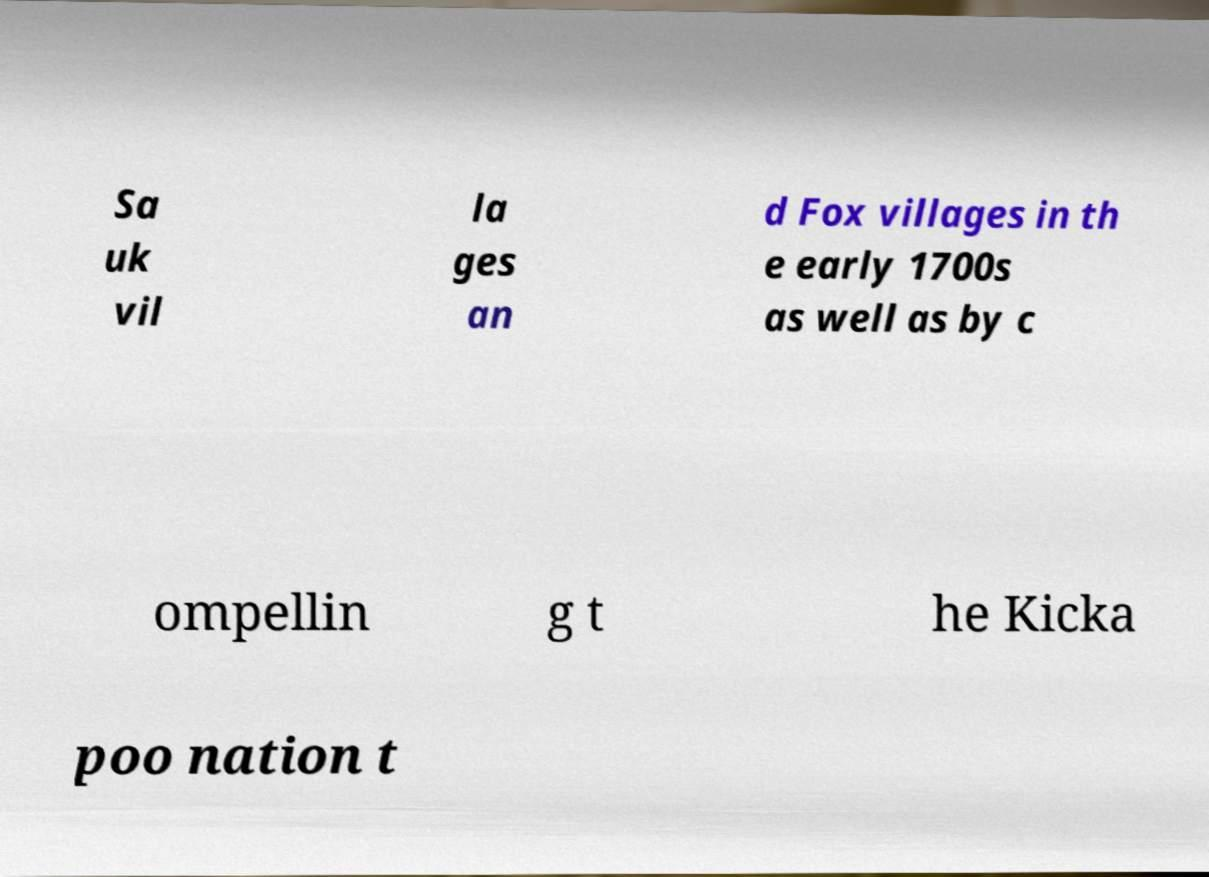Please read and relay the text visible in this image. What does it say? Sa uk vil la ges an d Fox villages in th e early 1700s as well as by c ompellin g t he Kicka poo nation t 